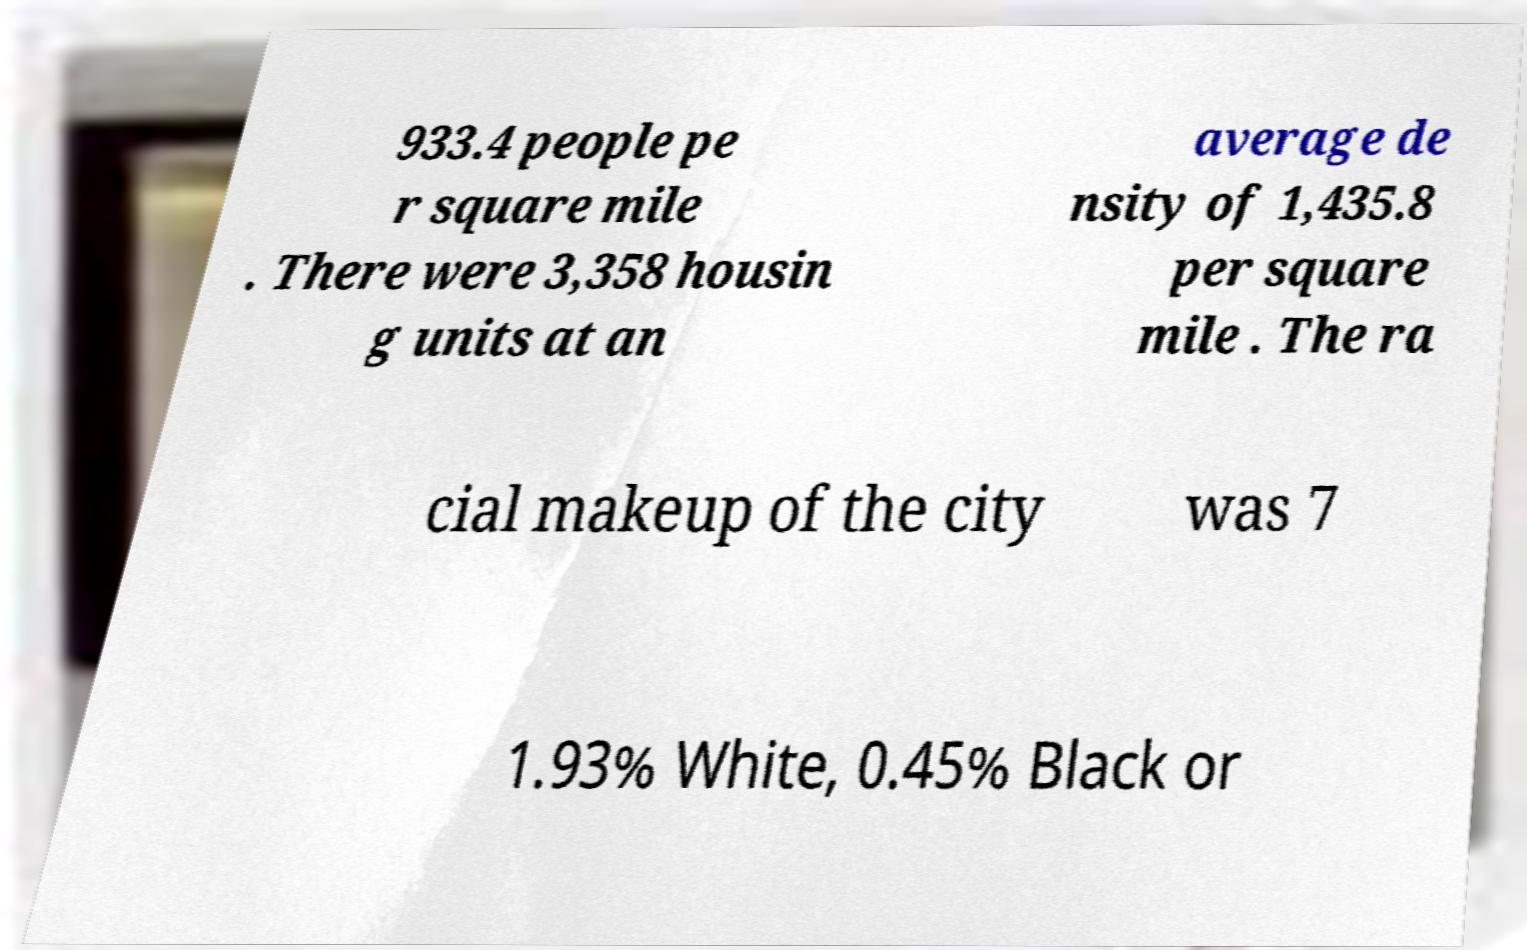For documentation purposes, I need the text within this image transcribed. Could you provide that? 933.4 people pe r square mile . There were 3,358 housin g units at an average de nsity of 1,435.8 per square mile . The ra cial makeup of the city was 7 1.93% White, 0.45% Black or 